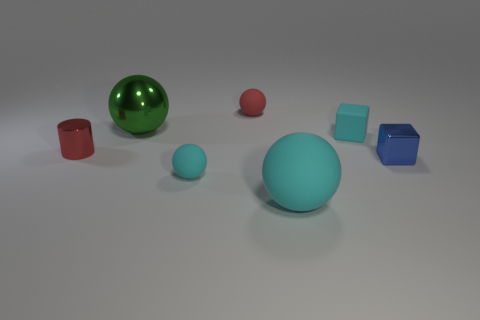Subtract 1 balls. How many balls are left? 3 Subtract all purple cylinders. Subtract all purple balls. How many cylinders are left? 1 Add 2 tiny cyan matte blocks. How many objects exist? 9 Subtract all cylinders. How many objects are left? 6 Add 4 big spheres. How many big spheres are left? 6 Add 5 metallic balls. How many metallic balls exist? 6 Subtract 1 green balls. How many objects are left? 6 Subtract all big cyan matte balls. Subtract all cyan matte cylinders. How many objects are left? 6 